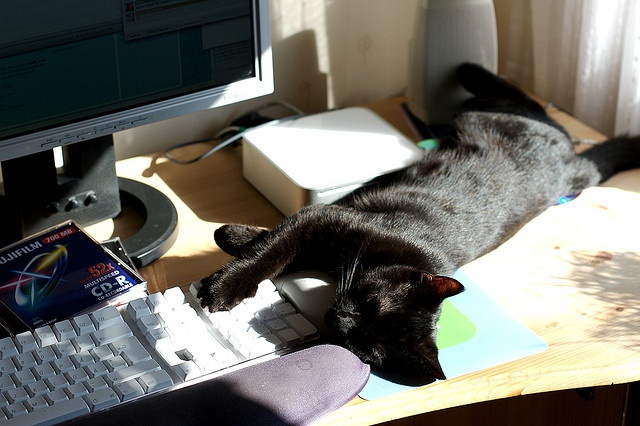Describe the objects in this image and their specific colors. I can see cat in black, darkgray, and gray tones, tv in black, gray, white, and darkgray tones, and keyboard in black, gray, white, and darkgray tones in this image. 